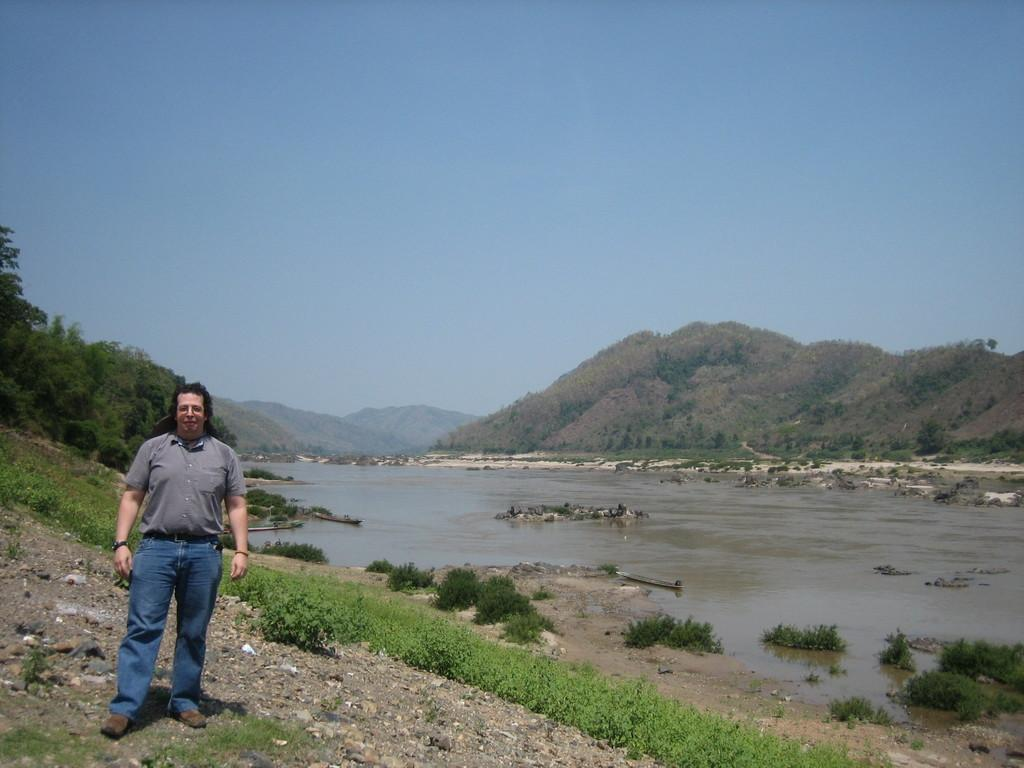What is the position of the man in the image? There is a man standing on the left side of the image. What can be seen near the man? There are trees near the man. What is present on the ground in the image? There are plants on the ground. What is visible in the background of the image? There is a river, hills, and the sky visible in the background of the image. How many tickets does the man have in his possession in the image? There is no mention of tickets in the image, so it cannot be determined if the man has any. 